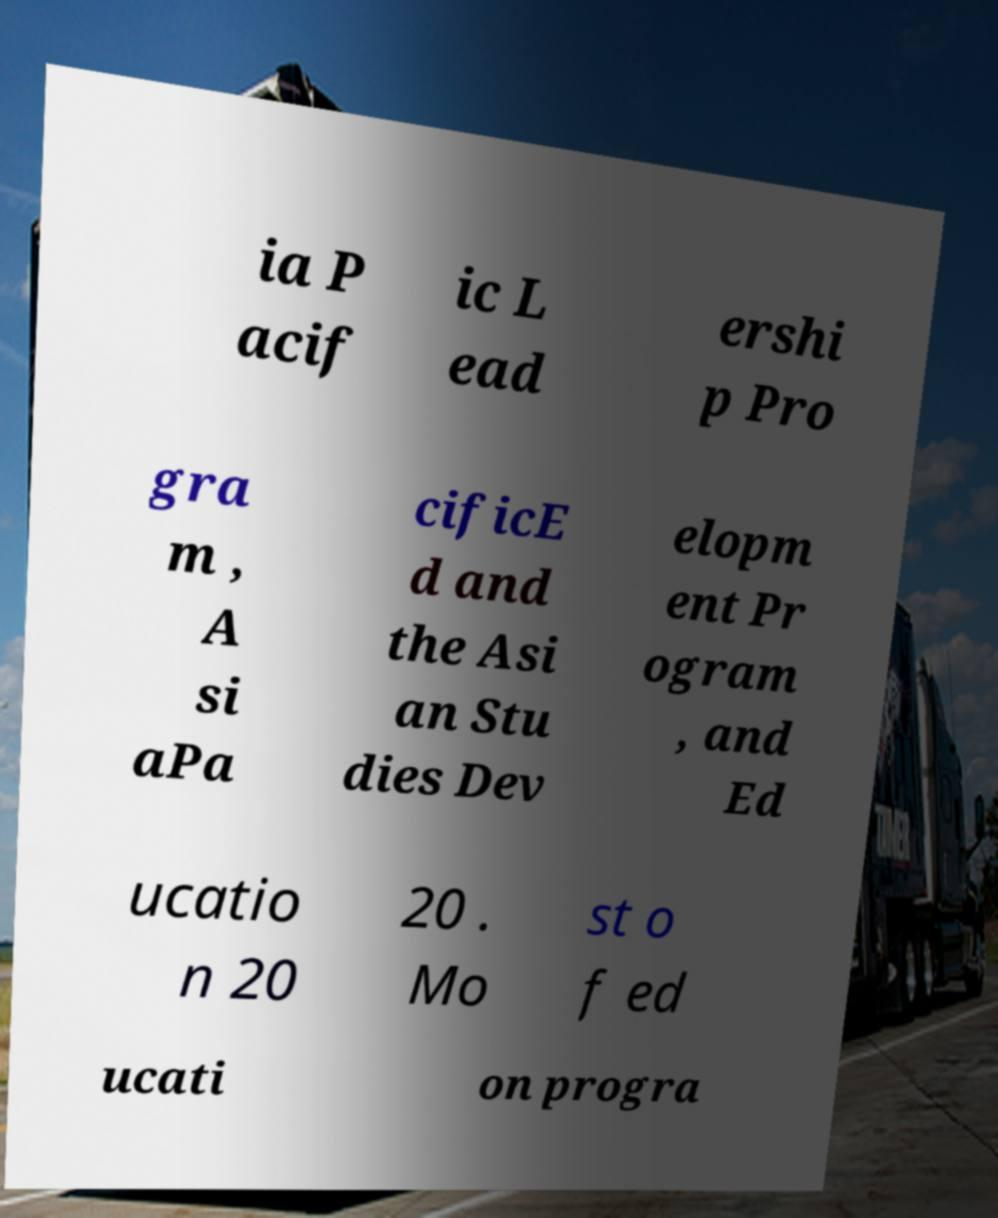There's text embedded in this image that I need extracted. Can you transcribe it verbatim? ia P acif ic L ead ershi p Pro gra m , A si aPa cificE d and the Asi an Stu dies Dev elopm ent Pr ogram , and Ed ucatio n 20 20 . Mo st o f ed ucati on progra 